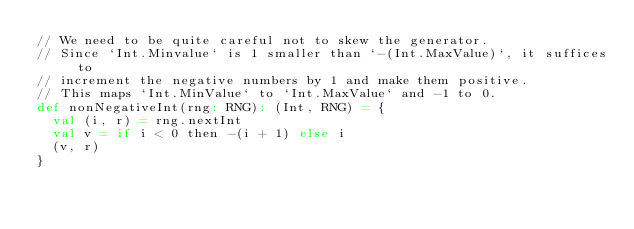<code> <loc_0><loc_0><loc_500><loc_500><_Scala_>// We need to be quite careful not to skew the generator.
// Since `Int.Minvalue` is 1 smaller than `-(Int.MaxValue)`, it suffices to
// increment the negative numbers by 1 and make them positive.
// This maps `Int.MinValue` to `Int.MaxValue` and -1 to 0.
def nonNegativeInt(rng: RNG): (Int, RNG) = {
  val (i, r) = rng.nextInt
  val v = if i < 0 then -(i + 1) else i
  (v, r)
}
</code> 